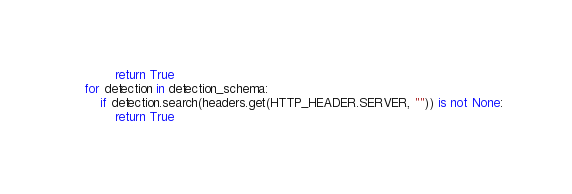Convert code to text. <code><loc_0><loc_0><loc_500><loc_500><_Python_>            return True
    for detection in detection_schema:
        if detection.search(headers.get(HTTP_HEADER.SERVER, "")) is not None:
            return True
</code> 